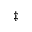Convert formula to latex. <formula><loc_0><loc_0><loc_500><loc_500>^ { \ddagger }</formula> 